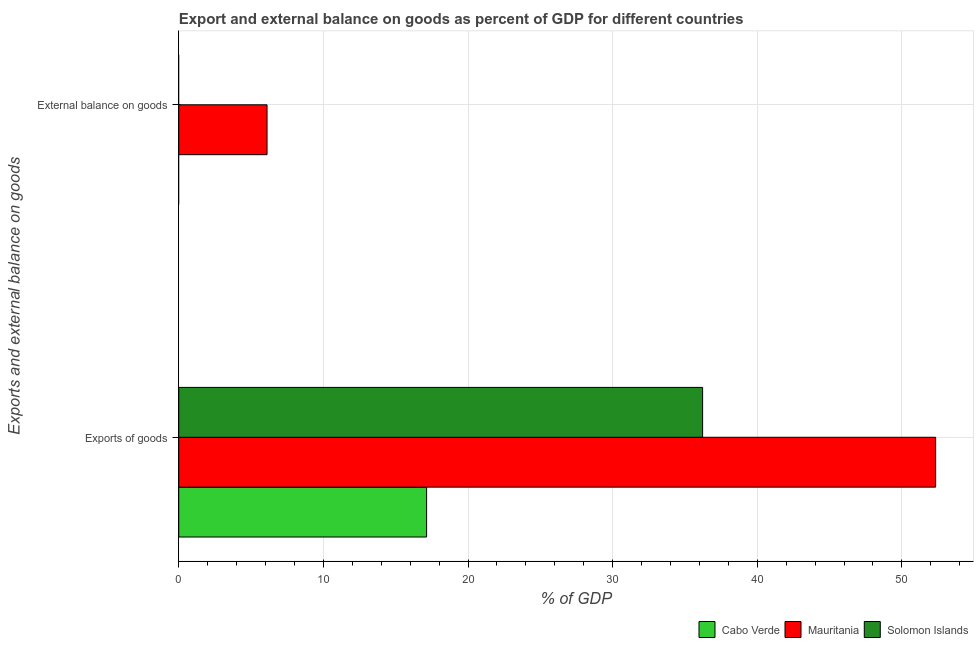How many different coloured bars are there?
Keep it short and to the point. 3. Are the number of bars per tick equal to the number of legend labels?
Make the answer very short. No. What is the label of the 1st group of bars from the top?
Offer a very short reply. External balance on goods. What is the export of goods as percentage of gdp in Cabo Verde?
Your answer should be compact. 17.14. Across all countries, what is the maximum external balance on goods as percentage of gdp?
Keep it short and to the point. 6.1. In which country was the external balance on goods as percentage of gdp maximum?
Give a very brief answer. Mauritania. What is the total export of goods as percentage of gdp in the graph?
Your response must be concise. 105.7. What is the difference between the export of goods as percentage of gdp in Mauritania and that in Cabo Verde?
Your answer should be compact. 35.2. What is the difference between the external balance on goods as percentage of gdp in Cabo Verde and the export of goods as percentage of gdp in Solomon Islands?
Your response must be concise. -36.22. What is the average export of goods as percentage of gdp per country?
Make the answer very short. 35.23. What is the difference between the external balance on goods as percentage of gdp and export of goods as percentage of gdp in Mauritania?
Your answer should be very brief. -46.23. What is the ratio of the export of goods as percentage of gdp in Mauritania to that in Solomon Islands?
Make the answer very short. 1.44. In how many countries, is the external balance on goods as percentage of gdp greater than the average external balance on goods as percentage of gdp taken over all countries?
Your response must be concise. 1. Are all the bars in the graph horizontal?
Your answer should be very brief. Yes. Are the values on the major ticks of X-axis written in scientific E-notation?
Keep it short and to the point. No. Does the graph contain grids?
Make the answer very short. Yes. Where does the legend appear in the graph?
Offer a very short reply. Bottom right. How many legend labels are there?
Ensure brevity in your answer.  3. How are the legend labels stacked?
Give a very brief answer. Horizontal. What is the title of the graph?
Make the answer very short. Export and external balance on goods as percent of GDP for different countries. What is the label or title of the X-axis?
Your response must be concise. % of GDP. What is the label or title of the Y-axis?
Give a very brief answer. Exports and external balance on goods. What is the % of GDP in Cabo Verde in Exports of goods?
Your answer should be compact. 17.14. What is the % of GDP in Mauritania in Exports of goods?
Your answer should be compact. 52.34. What is the % of GDP of Solomon Islands in Exports of goods?
Your answer should be compact. 36.22. What is the % of GDP in Mauritania in External balance on goods?
Make the answer very short. 6.1. What is the % of GDP of Solomon Islands in External balance on goods?
Your answer should be compact. 0. Across all Exports and external balance on goods, what is the maximum % of GDP in Cabo Verde?
Ensure brevity in your answer.  17.14. Across all Exports and external balance on goods, what is the maximum % of GDP in Mauritania?
Your response must be concise. 52.34. Across all Exports and external balance on goods, what is the maximum % of GDP of Solomon Islands?
Keep it short and to the point. 36.22. Across all Exports and external balance on goods, what is the minimum % of GDP of Mauritania?
Your response must be concise. 6.1. Across all Exports and external balance on goods, what is the minimum % of GDP of Solomon Islands?
Offer a very short reply. 0. What is the total % of GDP in Cabo Verde in the graph?
Your answer should be compact. 17.14. What is the total % of GDP of Mauritania in the graph?
Provide a short and direct response. 58.44. What is the total % of GDP in Solomon Islands in the graph?
Provide a succinct answer. 36.22. What is the difference between the % of GDP in Mauritania in Exports of goods and that in External balance on goods?
Offer a very short reply. 46.23. What is the difference between the % of GDP of Cabo Verde in Exports of goods and the % of GDP of Mauritania in External balance on goods?
Ensure brevity in your answer.  11.03. What is the average % of GDP of Cabo Verde per Exports and external balance on goods?
Provide a short and direct response. 8.57. What is the average % of GDP in Mauritania per Exports and external balance on goods?
Offer a very short reply. 29.22. What is the average % of GDP in Solomon Islands per Exports and external balance on goods?
Offer a very short reply. 18.11. What is the difference between the % of GDP in Cabo Verde and % of GDP in Mauritania in Exports of goods?
Give a very brief answer. -35.2. What is the difference between the % of GDP in Cabo Verde and % of GDP in Solomon Islands in Exports of goods?
Ensure brevity in your answer.  -19.09. What is the difference between the % of GDP of Mauritania and % of GDP of Solomon Islands in Exports of goods?
Offer a terse response. 16.11. What is the ratio of the % of GDP of Mauritania in Exports of goods to that in External balance on goods?
Your answer should be very brief. 8.57. What is the difference between the highest and the second highest % of GDP in Mauritania?
Your response must be concise. 46.23. What is the difference between the highest and the lowest % of GDP of Cabo Verde?
Give a very brief answer. 17.14. What is the difference between the highest and the lowest % of GDP of Mauritania?
Your response must be concise. 46.23. What is the difference between the highest and the lowest % of GDP of Solomon Islands?
Offer a terse response. 36.22. 